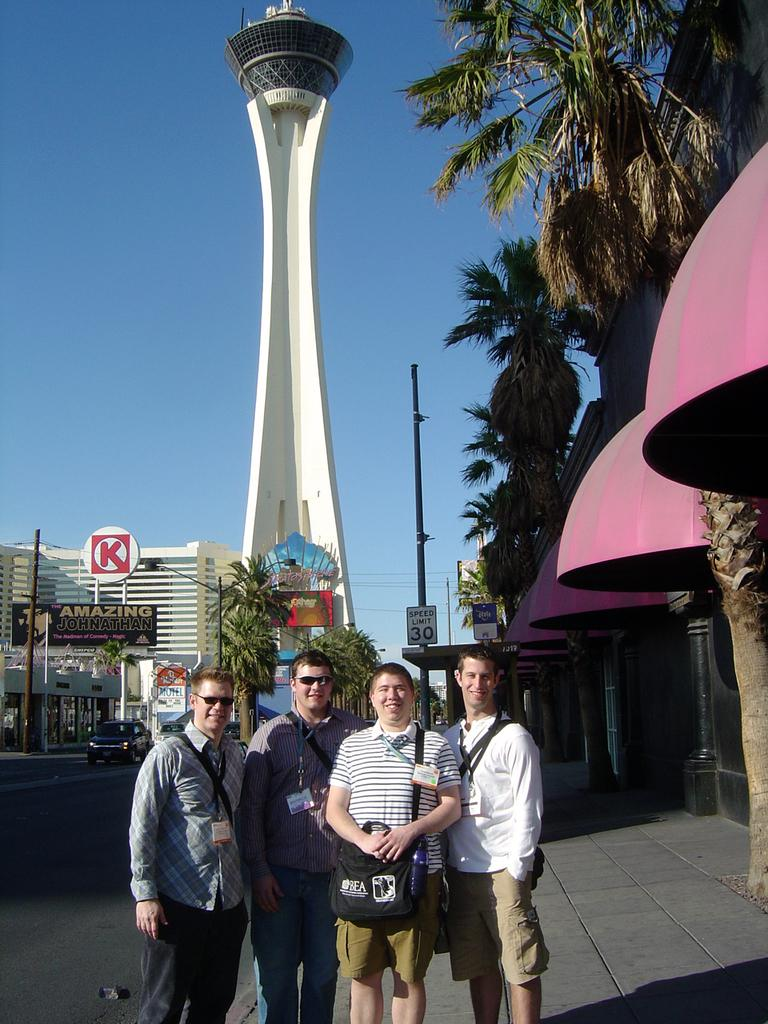What can be seen in the image? There are people standing in the image. What type of vegetation is present in the image? There is a green tree in the image. What type of structure is visible in the image? There is a building in the image. What is visible at the top of the image? The sky is blue and visible at the top of the image. How many drops of water can be seen falling from the tree in the image? There are no drops of water visible in the image; it only shows a green tree. What type of scale is used to weigh the building in the image? There is no scale present in the image, and the building is not being weighed. 